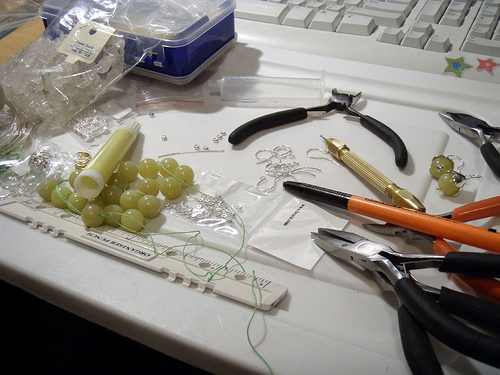<image>
Is there a star on the keyboard? Yes. Looking at the image, I can see the star is positioned on top of the keyboard, with the keyboard providing support. Is the confetti in front of the keyboard? No. The confetti is not in front of the keyboard. The spatial positioning shows a different relationship between these objects. 